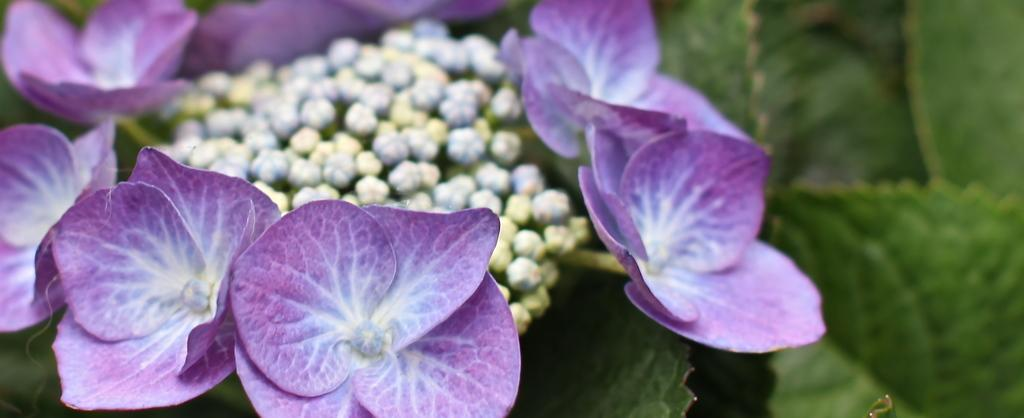What type of plants can be seen in the image? There are flowers in the image. What colors are the flowers? The flowers are in violet and white colors. What else is present in the image besides the flowers? There are leaves in the image. What color are the leaves? The leaves are in green color. Can you see a kettle boiling in the image? No, there is no kettle present in the image. What type of fear is depicted in the image? There is no fear depicted in the image; it features flowers and leaves. 